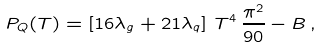Convert formula to latex. <formula><loc_0><loc_0><loc_500><loc_500>P _ { Q } ( T ) = \left [ 1 6 \lambda _ { g } + 2 1 \lambda _ { q } \right ] \, T ^ { 4 } \, \frac { \pi ^ { 2 } } { 9 0 } - B \, ,</formula> 